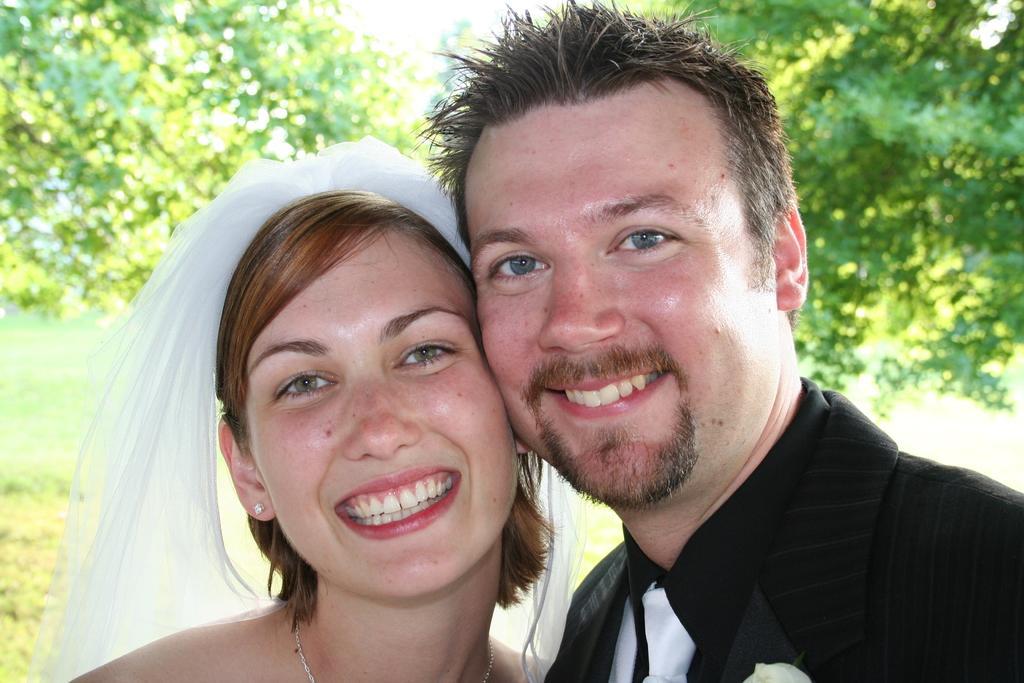Describe this image in one or two sentences. In this image we can see two people smiling, behind them there are some trees and also we can see the sky. 